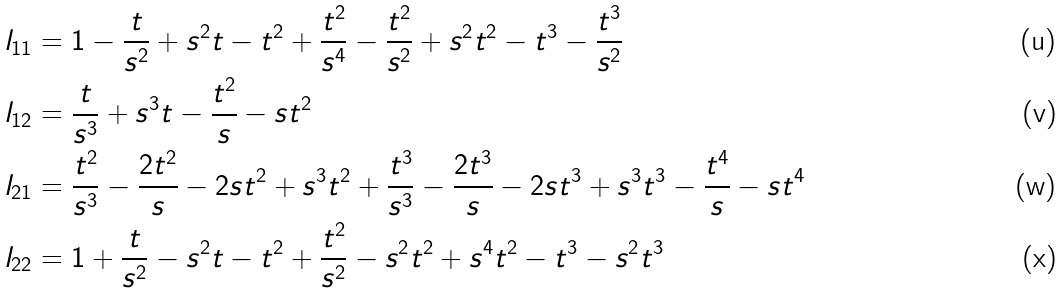Convert formula to latex. <formula><loc_0><loc_0><loc_500><loc_500>l _ { 1 1 } & = 1 - \frac { t } { s ^ { 2 } } + s ^ { 2 } t - t ^ { 2 } + \frac { t ^ { 2 } } { s ^ { 4 } } - \frac { t ^ { 2 } } { s ^ { 2 } } + s ^ { 2 } t ^ { 2 } - t ^ { 3 } - \frac { t ^ { 3 } } { s ^ { 2 } } \\ l _ { 1 2 } & = \frac { t } { s ^ { 3 } } + s ^ { 3 } t - \frac { t ^ { 2 } } { s } - s t ^ { 2 } \\ l _ { 2 1 } & = \frac { t ^ { 2 } } { s ^ { 3 } } - \frac { 2 t ^ { 2 } } { s } - 2 s t ^ { 2 } + s ^ { 3 } t ^ { 2 } + \frac { t ^ { 3 } } { s ^ { 3 } } - \frac { 2 t ^ { 3 } } { s } - 2 s t ^ { 3 } + s ^ { 3 } t ^ { 3 } - \frac { t ^ { 4 } } { s } - s t ^ { 4 } \\ l _ { 2 2 } & = 1 + \frac { t } { s ^ { 2 } } - s ^ { 2 } t - t ^ { 2 } + \frac { t ^ { 2 } } { s ^ { 2 } } - s ^ { 2 } t ^ { 2 } + s ^ { 4 } t ^ { 2 } - t ^ { 3 } - s ^ { 2 } t ^ { 3 }</formula> 